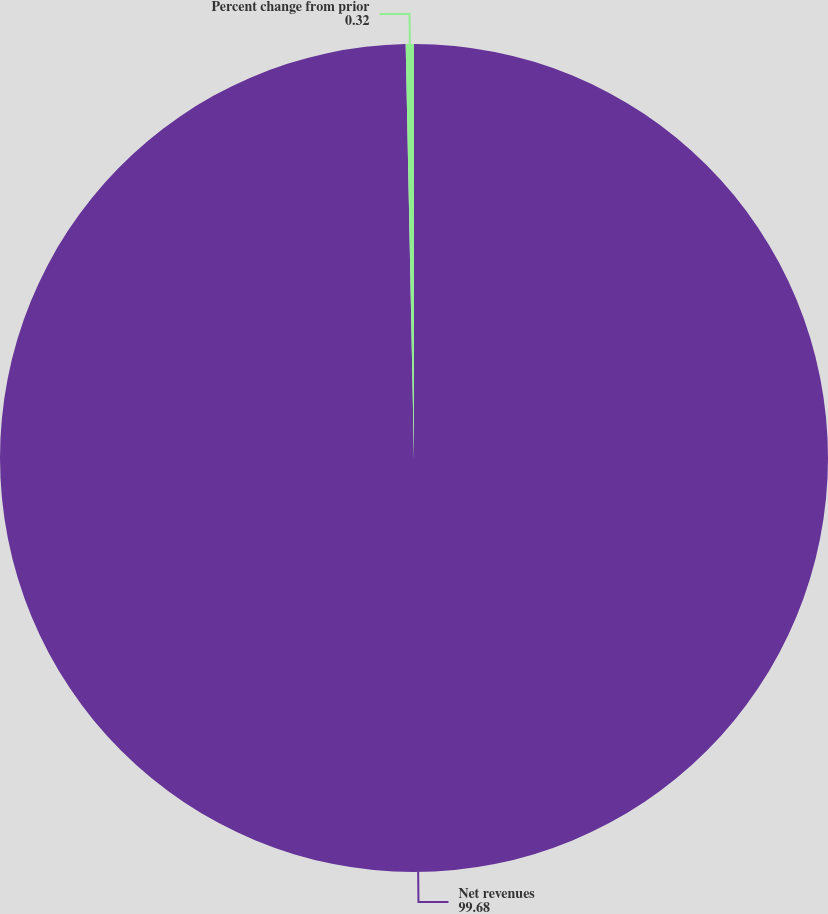<chart> <loc_0><loc_0><loc_500><loc_500><pie_chart><fcel>Net revenues<fcel>Percent change from prior<nl><fcel>99.68%<fcel>0.32%<nl></chart> 